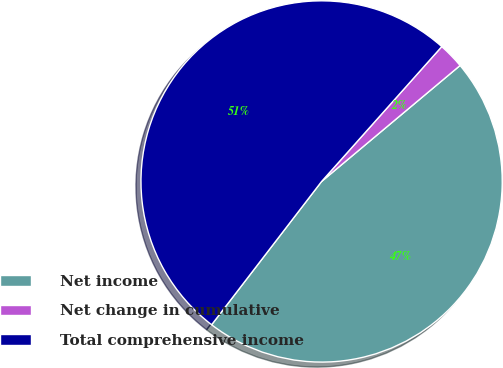<chart> <loc_0><loc_0><loc_500><loc_500><pie_chart><fcel>Net income<fcel>Net change in cumulative<fcel>Total comprehensive income<nl><fcel>46.51%<fcel>2.32%<fcel>51.16%<nl></chart> 